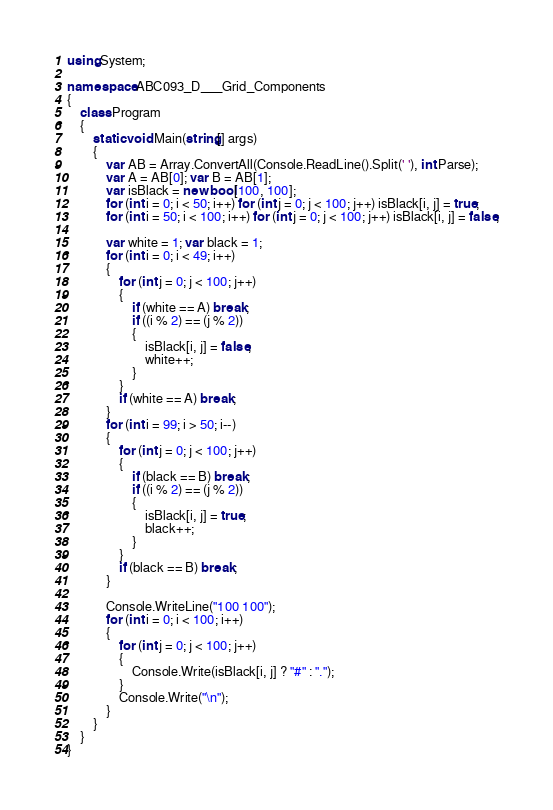<code> <loc_0><loc_0><loc_500><loc_500><_C#_>using System;

namespace ABC093_D___Grid_Components
{
    class Program
    {
        static void Main(string[] args)
        {
            var AB = Array.ConvertAll(Console.ReadLine().Split(' '), int.Parse);
            var A = AB[0]; var B = AB[1];
            var isBlack = new bool[100, 100];
            for (int i = 0; i < 50; i++) for (int j = 0; j < 100; j++) isBlack[i, j] = true;
            for (int i = 50; i < 100; i++) for (int j = 0; j < 100; j++) isBlack[i, j] = false;

            var white = 1; var black = 1;
            for (int i = 0; i < 49; i++)
            {
                for (int j = 0; j < 100; j++)
                {
                    if (white == A) break;
                    if ((i % 2) == (j % 2))
                    {
                        isBlack[i, j] = false;
                        white++;
                    }
                }
                if (white == A) break;
            }
            for (int i = 99; i > 50; i--)
            {
                for (int j = 0; j < 100; j++)
                {
                    if (black == B) break;
                    if ((i % 2) == (j % 2))
                    {
                        isBlack[i, j] = true;
                        black++;
                    }
                }
                if (black == B) break;
            }

            Console.WriteLine("100 100");
            for (int i = 0; i < 100; i++)
            {
                for (int j = 0; j < 100; j++)
                {
                    Console.Write(isBlack[i, j] ? "#" : ".");
                }
                Console.Write("\n");
            }
        }
    }
}
</code> 